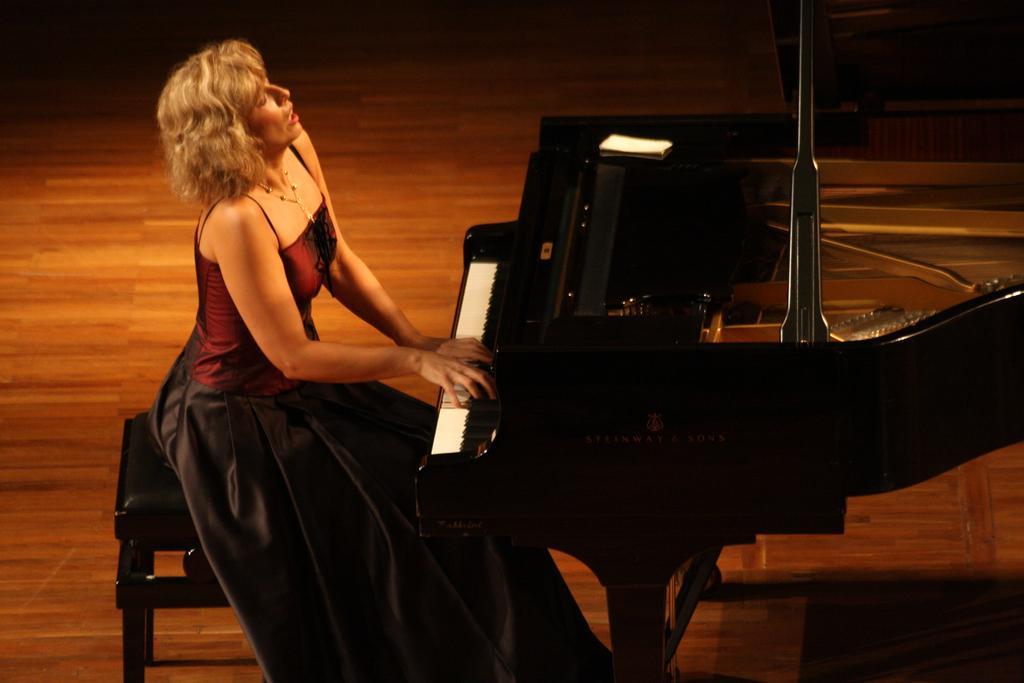Could you give a brief overview of what you see in this image? This woman is sitting on a chair and playing piano. This is piano keyboard. 